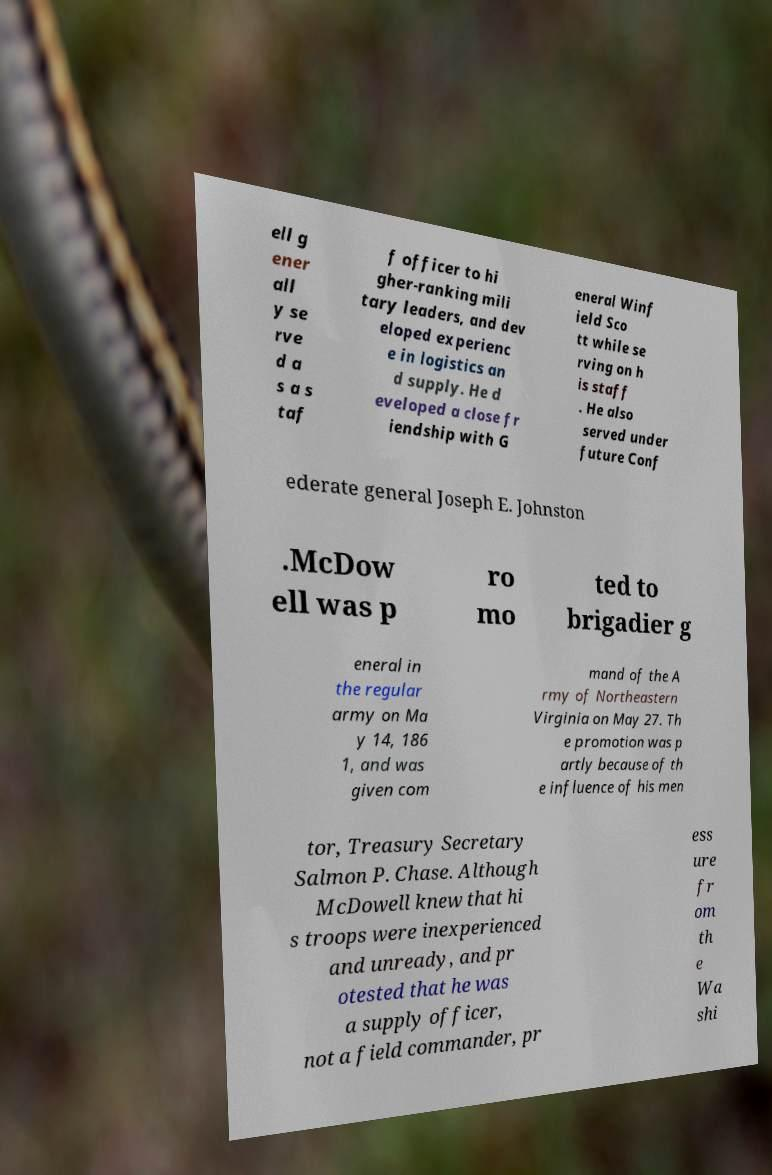Can you read and provide the text displayed in the image?This photo seems to have some interesting text. Can you extract and type it out for me? ell g ener all y se rve d a s a s taf f officer to hi gher-ranking mili tary leaders, and dev eloped experienc e in logistics an d supply. He d eveloped a close fr iendship with G eneral Winf ield Sco tt while se rving on h is staff . He also served under future Conf ederate general Joseph E. Johnston .McDow ell was p ro mo ted to brigadier g eneral in the regular army on Ma y 14, 186 1, and was given com mand of the A rmy of Northeastern Virginia on May 27. Th e promotion was p artly because of th e influence of his men tor, Treasury Secretary Salmon P. Chase. Although McDowell knew that hi s troops were inexperienced and unready, and pr otested that he was a supply officer, not a field commander, pr ess ure fr om th e Wa shi 